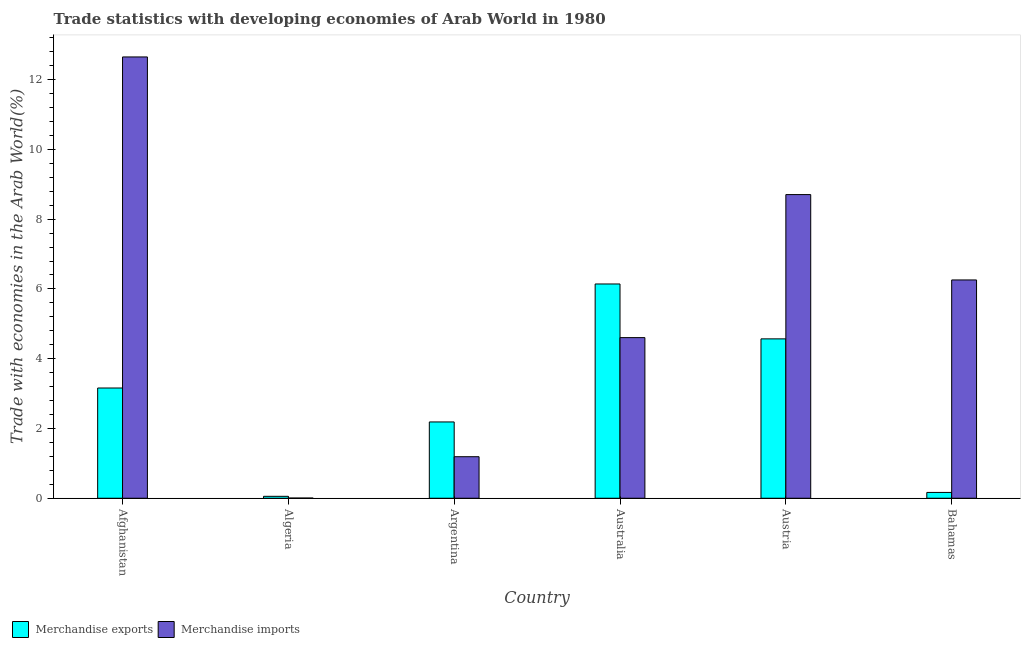How many groups of bars are there?
Provide a succinct answer. 6. Are the number of bars on each tick of the X-axis equal?
Your answer should be very brief. Yes. How many bars are there on the 1st tick from the left?
Provide a short and direct response. 2. How many bars are there on the 4th tick from the right?
Provide a succinct answer. 2. What is the merchandise imports in Australia?
Ensure brevity in your answer.  4.6. Across all countries, what is the maximum merchandise exports?
Offer a terse response. 6.14. Across all countries, what is the minimum merchandise exports?
Your answer should be compact. 0.06. In which country was the merchandise imports maximum?
Your answer should be very brief. Afghanistan. In which country was the merchandise exports minimum?
Keep it short and to the point. Algeria. What is the total merchandise exports in the graph?
Keep it short and to the point. 16.28. What is the difference between the merchandise exports in Algeria and that in Austria?
Your answer should be compact. -4.51. What is the difference between the merchandise exports in Australia and the merchandise imports in Austria?
Your answer should be very brief. -2.56. What is the average merchandise imports per country?
Offer a very short reply. 5.57. What is the difference between the merchandise imports and merchandise exports in Austria?
Offer a very short reply. 4.14. What is the ratio of the merchandise imports in Afghanistan to that in Bahamas?
Provide a short and direct response. 2.02. Is the merchandise imports in Afghanistan less than that in Bahamas?
Provide a succinct answer. No. What is the difference between the highest and the second highest merchandise imports?
Your response must be concise. 3.95. What is the difference between the highest and the lowest merchandise imports?
Provide a succinct answer. 12.65. What does the 2nd bar from the left in Bahamas represents?
Keep it short and to the point. Merchandise imports. What does the 2nd bar from the right in Argentina represents?
Your response must be concise. Merchandise exports. Are all the bars in the graph horizontal?
Provide a short and direct response. No. How many countries are there in the graph?
Offer a very short reply. 6. What is the difference between two consecutive major ticks on the Y-axis?
Offer a very short reply. 2. Are the values on the major ticks of Y-axis written in scientific E-notation?
Your response must be concise. No. Does the graph contain any zero values?
Offer a terse response. No. Does the graph contain grids?
Keep it short and to the point. No. How many legend labels are there?
Make the answer very short. 2. How are the legend labels stacked?
Give a very brief answer. Horizontal. What is the title of the graph?
Your answer should be very brief. Trade statistics with developing economies of Arab World in 1980. Does "Domestic liabilities" appear as one of the legend labels in the graph?
Give a very brief answer. No. What is the label or title of the X-axis?
Make the answer very short. Country. What is the label or title of the Y-axis?
Offer a terse response. Trade with economies in the Arab World(%). What is the Trade with economies in the Arab World(%) of Merchandise exports in Afghanistan?
Make the answer very short. 3.16. What is the Trade with economies in the Arab World(%) of Merchandise imports in Afghanistan?
Offer a very short reply. 12.65. What is the Trade with economies in the Arab World(%) in Merchandise exports in Algeria?
Provide a short and direct response. 0.06. What is the Trade with economies in the Arab World(%) of Merchandise imports in Algeria?
Offer a very short reply. 0.01. What is the Trade with economies in the Arab World(%) in Merchandise exports in Argentina?
Your response must be concise. 2.19. What is the Trade with economies in the Arab World(%) in Merchandise imports in Argentina?
Make the answer very short. 1.19. What is the Trade with economies in the Arab World(%) of Merchandise exports in Australia?
Provide a short and direct response. 6.14. What is the Trade with economies in the Arab World(%) in Merchandise imports in Australia?
Your answer should be very brief. 4.6. What is the Trade with economies in the Arab World(%) in Merchandise exports in Austria?
Offer a terse response. 4.57. What is the Trade with economies in the Arab World(%) of Merchandise imports in Austria?
Your answer should be very brief. 8.7. What is the Trade with economies in the Arab World(%) in Merchandise exports in Bahamas?
Offer a very short reply. 0.17. What is the Trade with economies in the Arab World(%) in Merchandise imports in Bahamas?
Provide a succinct answer. 6.26. Across all countries, what is the maximum Trade with economies in the Arab World(%) of Merchandise exports?
Provide a short and direct response. 6.14. Across all countries, what is the maximum Trade with economies in the Arab World(%) in Merchandise imports?
Ensure brevity in your answer.  12.65. Across all countries, what is the minimum Trade with economies in the Arab World(%) of Merchandise exports?
Provide a short and direct response. 0.06. Across all countries, what is the minimum Trade with economies in the Arab World(%) in Merchandise imports?
Provide a succinct answer. 0.01. What is the total Trade with economies in the Arab World(%) in Merchandise exports in the graph?
Keep it short and to the point. 16.28. What is the total Trade with economies in the Arab World(%) in Merchandise imports in the graph?
Your answer should be very brief. 33.41. What is the difference between the Trade with economies in the Arab World(%) in Merchandise exports in Afghanistan and that in Algeria?
Your response must be concise. 3.1. What is the difference between the Trade with economies in the Arab World(%) of Merchandise imports in Afghanistan and that in Algeria?
Make the answer very short. 12.65. What is the difference between the Trade with economies in the Arab World(%) in Merchandise exports in Afghanistan and that in Argentina?
Your answer should be compact. 0.97. What is the difference between the Trade with economies in the Arab World(%) in Merchandise imports in Afghanistan and that in Argentina?
Ensure brevity in your answer.  11.46. What is the difference between the Trade with economies in the Arab World(%) in Merchandise exports in Afghanistan and that in Australia?
Offer a very short reply. -2.98. What is the difference between the Trade with economies in the Arab World(%) in Merchandise imports in Afghanistan and that in Australia?
Give a very brief answer. 8.05. What is the difference between the Trade with economies in the Arab World(%) in Merchandise exports in Afghanistan and that in Austria?
Provide a short and direct response. -1.41. What is the difference between the Trade with economies in the Arab World(%) of Merchandise imports in Afghanistan and that in Austria?
Offer a terse response. 3.95. What is the difference between the Trade with economies in the Arab World(%) of Merchandise exports in Afghanistan and that in Bahamas?
Provide a short and direct response. 2.99. What is the difference between the Trade with economies in the Arab World(%) in Merchandise imports in Afghanistan and that in Bahamas?
Your answer should be very brief. 6.39. What is the difference between the Trade with economies in the Arab World(%) of Merchandise exports in Algeria and that in Argentina?
Offer a terse response. -2.13. What is the difference between the Trade with economies in the Arab World(%) of Merchandise imports in Algeria and that in Argentina?
Provide a succinct answer. -1.19. What is the difference between the Trade with economies in the Arab World(%) in Merchandise exports in Algeria and that in Australia?
Ensure brevity in your answer.  -6.09. What is the difference between the Trade with economies in the Arab World(%) of Merchandise imports in Algeria and that in Australia?
Ensure brevity in your answer.  -4.6. What is the difference between the Trade with economies in the Arab World(%) in Merchandise exports in Algeria and that in Austria?
Keep it short and to the point. -4.51. What is the difference between the Trade with economies in the Arab World(%) of Merchandise imports in Algeria and that in Austria?
Your answer should be compact. -8.7. What is the difference between the Trade with economies in the Arab World(%) in Merchandise exports in Algeria and that in Bahamas?
Give a very brief answer. -0.11. What is the difference between the Trade with economies in the Arab World(%) in Merchandise imports in Algeria and that in Bahamas?
Provide a short and direct response. -6.25. What is the difference between the Trade with economies in the Arab World(%) in Merchandise exports in Argentina and that in Australia?
Your response must be concise. -3.95. What is the difference between the Trade with economies in the Arab World(%) in Merchandise imports in Argentina and that in Australia?
Offer a terse response. -3.41. What is the difference between the Trade with economies in the Arab World(%) in Merchandise exports in Argentina and that in Austria?
Provide a succinct answer. -2.38. What is the difference between the Trade with economies in the Arab World(%) of Merchandise imports in Argentina and that in Austria?
Provide a succinct answer. -7.51. What is the difference between the Trade with economies in the Arab World(%) of Merchandise exports in Argentina and that in Bahamas?
Provide a succinct answer. 2.02. What is the difference between the Trade with economies in the Arab World(%) in Merchandise imports in Argentina and that in Bahamas?
Give a very brief answer. -5.07. What is the difference between the Trade with economies in the Arab World(%) in Merchandise exports in Australia and that in Austria?
Provide a short and direct response. 1.57. What is the difference between the Trade with economies in the Arab World(%) in Merchandise imports in Australia and that in Austria?
Keep it short and to the point. -4.1. What is the difference between the Trade with economies in the Arab World(%) in Merchandise exports in Australia and that in Bahamas?
Offer a terse response. 5.98. What is the difference between the Trade with economies in the Arab World(%) of Merchandise imports in Australia and that in Bahamas?
Provide a succinct answer. -1.65. What is the difference between the Trade with economies in the Arab World(%) in Merchandise exports in Austria and that in Bahamas?
Your answer should be very brief. 4.4. What is the difference between the Trade with economies in the Arab World(%) of Merchandise imports in Austria and that in Bahamas?
Your response must be concise. 2.45. What is the difference between the Trade with economies in the Arab World(%) in Merchandise exports in Afghanistan and the Trade with economies in the Arab World(%) in Merchandise imports in Algeria?
Give a very brief answer. 3.15. What is the difference between the Trade with economies in the Arab World(%) in Merchandise exports in Afghanistan and the Trade with economies in the Arab World(%) in Merchandise imports in Argentina?
Provide a short and direct response. 1.97. What is the difference between the Trade with economies in the Arab World(%) in Merchandise exports in Afghanistan and the Trade with economies in the Arab World(%) in Merchandise imports in Australia?
Provide a succinct answer. -1.44. What is the difference between the Trade with economies in the Arab World(%) in Merchandise exports in Afghanistan and the Trade with economies in the Arab World(%) in Merchandise imports in Austria?
Offer a terse response. -5.54. What is the difference between the Trade with economies in the Arab World(%) of Merchandise exports in Afghanistan and the Trade with economies in the Arab World(%) of Merchandise imports in Bahamas?
Make the answer very short. -3.1. What is the difference between the Trade with economies in the Arab World(%) of Merchandise exports in Algeria and the Trade with economies in the Arab World(%) of Merchandise imports in Argentina?
Make the answer very short. -1.14. What is the difference between the Trade with economies in the Arab World(%) in Merchandise exports in Algeria and the Trade with economies in the Arab World(%) in Merchandise imports in Australia?
Offer a very short reply. -4.55. What is the difference between the Trade with economies in the Arab World(%) of Merchandise exports in Algeria and the Trade with economies in the Arab World(%) of Merchandise imports in Austria?
Your response must be concise. -8.65. What is the difference between the Trade with economies in the Arab World(%) in Merchandise exports in Algeria and the Trade with economies in the Arab World(%) in Merchandise imports in Bahamas?
Offer a very short reply. -6.2. What is the difference between the Trade with economies in the Arab World(%) of Merchandise exports in Argentina and the Trade with economies in the Arab World(%) of Merchandise imports in Australia?
Offer a very short reply. -2.42. What is the difference between the Trade with economies in the Arab World(%) of Merchandise exports in Argentina and the Trade with economies in the Arab World(%) of Merchandise imports in Austria?
Ensure brevity in your answer.  -6.52. What is the difference between the Trade with economies in the Arab World(%) in Merchandise exports in Argentina and the Trade with economies in the Arab World(%) in Merchandise imports in Bahamas?
Offer a terse response. -4.07. What is the difference between the Trade with economies in the Arab World(%) of Merchandise exports in Australia and the Trade with economies in the Arab World(%) of Merchandise imports in Austria?
Your answer should be very brief. -2.56. What is the difference between the Trade with economies in the Arab World(%) in Merchandise exports in Australia and the Trade with economies in the Arab World(%) in Merchandise imports in Bahamas?
Provide a succinct answer. -0.12. What is the difference between the Trade with economies in the Arab World(%) in Merchandise exports in Austria and the Trade with economies in the Arab World(%) in Merchandise imports in Bahamas?
Provide a short and direct response. -1.69. What is the average Trade with economies in the Arab World(%) in Merchandise exports per country?
Provide a short and direct response. 2.71. What is the average Trade with economies in the Arab World(%) of Merchandise imports per country?
Offer a very short reply. 5.57. What is the difference between the Trade with economies in the Arab World(%) in Merchandise exports and Trade with economies in the Arab World(%) in Merchandise imports in Afghanistan?
Offer a very short reply. -9.49. What is the difference between the Trade with economies in the Arab World(%) of Merchandise exports and Trade with economies in the Arab World(%) of Merchandise imports in Algeria?
Offer a very short reply. 0.05. What is the difference between the Trade with economies in the Arab World(%) in Merchandise exports and Trade with economies in the Arab World(%) in Merchandise imports in Argentina?
Offer a terse response. 1. What is the difference between the Trade with economies in the Arab World(%) of Merchandise exports and Trade with economies in the Arab World(%) of Merchandise imports in Australia?
Keep it short and to the point. 1.54. What is the difference between the Trade with economies in the Arab World(%) of Merchandise exports and Trade with economies in the Arab World(%) of Merchandise imports in Austria?
Make the answer very short. -4.14. What is the difference between the Trade with economies in the Arab World(%) of Merchandise exports and Trade with economies in the Arab World(%) of Merchandise imports in Bahamas?
Give a very brief answer. -6.09. What is the ratio of the Trade with economies in the Arab World(%) of Merchandise exports in Afghanistan to that in Algeria?
Give a very brief answer. 57.34. What is the ratio of the Trade with economies in the Arab World(%) of Merchandise imports in Afghanistan to that in Algeria?
Your answer should be compact. 2407.27. What is the ratio of the Trade with economies in the Arab World(%) of Merchandise exports in Afghanistan to that in Argentina?
Offer a very short reply. 1.44. What is the ratio of the Trade with economies in the Arab World(%) of Merchandise imports in Afghanistan to that in Argentina?
Your answer should be compact. 10.62. What is the ratio of the Trade with economies in the Arab World(%) of Merchandise exports in Afghanistan to that in Australia?
Your answer should be compact. 0.51. What is the ratio of the Trade with economies in the Arab World(%) in Merchandise imports in Afghanistan to that in Australia?
Provide a succinct answer. 2.75. What is the ratio of the Trade with economies in the Arab World(%) in Merchandise exports in Afghanistan to that in Austria?
Provide a succinct answer. 0.69. What is the ratio of the Trade with economies in the Arab World(%) in Merchandise imports in Afghanistan to that in Austria?
Give a very brief answer. 1.45. What is the ratio of the Trade with economies in the Arab World(%) in Merchandise exports in Afghanistan to that in Bahamas?
Offer a terse response. 18.98. What is the ratio of the Trade with economies in the Arab World(%) of Merchandise imports in Afghanistan to that in Bahamas?
Offer a terse response. 2.02. What is the ratio of the Trade with economies in the Arab World(%) of Merchandise exports in Algeria to that in Argentina?
Make the answer very short. 0.03. What is the ratio of the Trade with economies in the Arab World(%) in Merchandise imports in Algeria to that in Argentina?
Make the answer very short. 0. What is the ratio of the Trade with economies in the Arab World(%) in Merchandise exports in Algeria to that in Australia?
Your answer should be compact. 0.01. What is the ratio of the Trade with economies in the Arab World(%) of Merchandise imports in Algeria to that in Australia?
Give a very brief answer. 0. What is the ratio of the Trade with economies in the Arab World(%) of Merchandise exports in Algeria to that in Austria?
Your answer should be compact. 0.01. What is the ratio of the Trade with economies in the Arab World(%) in Merchandise imports in Algeria to that in Austria?
Keep it short and to the point. 0. What is the ratio of the Trade with economies in the Arab World(%) in Merchandise exports in Algeria to that in Bahamas?
Give a very brief answer. 0.33. What is the ratio of the Trade with economies in the Arab World(%) of Merchandise imports in Algeria to that in Bahamas?
Keep it short and to the point. 0. What is the ratio of the Trade with economies in the Arab World(%) in Merchandise exports in Argentina to that in Australia?
Make the answer very short. 0.36. What is the ratio of the Trade with economies in the Arab World(%) of Merchandise imports in Argentina to that in Australia?
Provide a succinct answer. 0.26. What is the ratio of the Trade with economies in the Arab World(%) in Merchandise exports in Argentina to that in Austria?
Offer a terse response. 0.48. What is the ratio of the Trade with economies in the Arab World(%) of Merchandise imports in Argentina to that in Austria?
Your answer should be compact. 0.14. What is the ratio of the Trade with economies in the Arab World(%) in Merchandise exports in Argentina to that in Bahamas?
Give a very brief answer. 13.13. What is the ratio of the Trade with economies in the Arab World(%) of Merchandise imports in Argentina to that in Bahamas?
Offer a very short reply. 0.19. What is the ratio of the Trade with economies in the Arab World(%) of Merchandise exports in Australia to that in Austria?
Ensure brevity in your answer.  1.34. What is the ratio of the Trade with economies in the Arab World(%) in Merchandise imports in Australia to that in Austria?
Your answer should be compact. 0.53. What is the ratio of the Trade with economies in the Arab World(%) in Merchandise exports in Australia to that in Bahamas?
Your response must be concise. 36.88. What is the ratio of the Trade with economies in the Arab World(%) of Merchandise imports in Australia to that in Bahamas?
Ensure brevity in your answer.  0.74. What is the ratio of the Trade with economies in the Arab World(%) of Merchandise exports in Austria to that in Bahamas?
Your answer should be compact. 27.43. What is the ratio of the Trade with economies in the Arab World(%) in Merchandise imports in Austria to that in Bahamas?
Ensure brevity in your answer.  1.39. What is the difference between the highest and the second highest Trade with economies in the Arab World(%) in Merchandise exports?
Ensure brevity in your answer.  1.57. What is the difference between the highest and the second highest Trade with economies in the Arab World(%) in Merchandise imports?
Keep it short and to the point. 3.95. What is the difference between the highest and the lowest Trade with economies in the Arab World(%) of Merchandise exports?
Offer a very short reply. 6.09. What is the difference between the highest and the lowest Trade with economies in the Arab World(%) of Merchandise imports?
Your answer should be very brief. 12.65. 